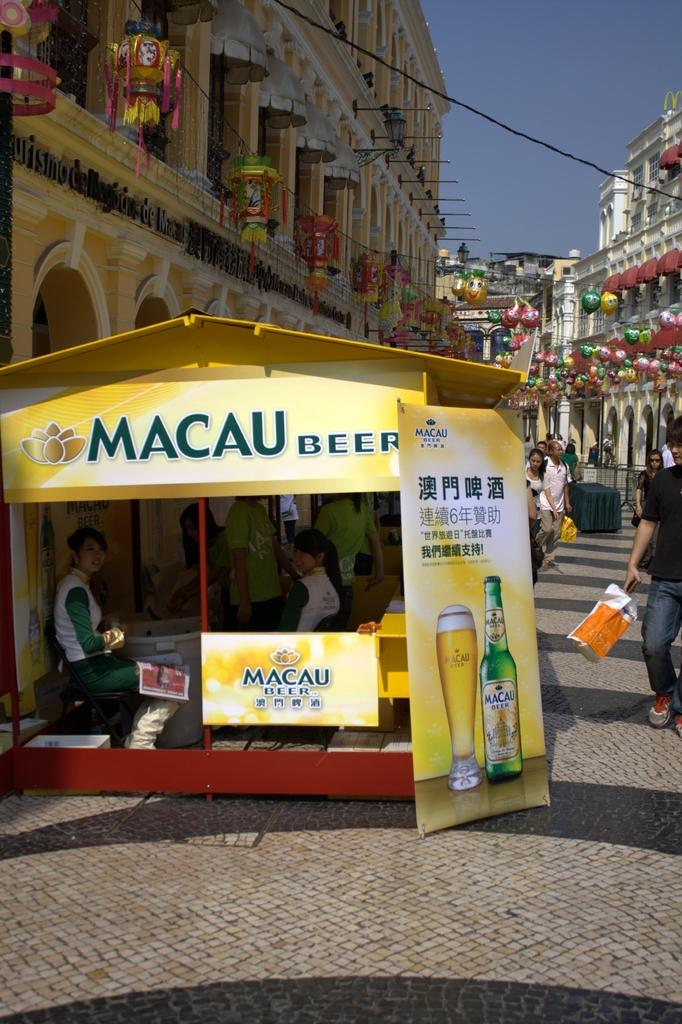Provide a one-sentence caption for the provided image. a Macau Beer location with people in it. 